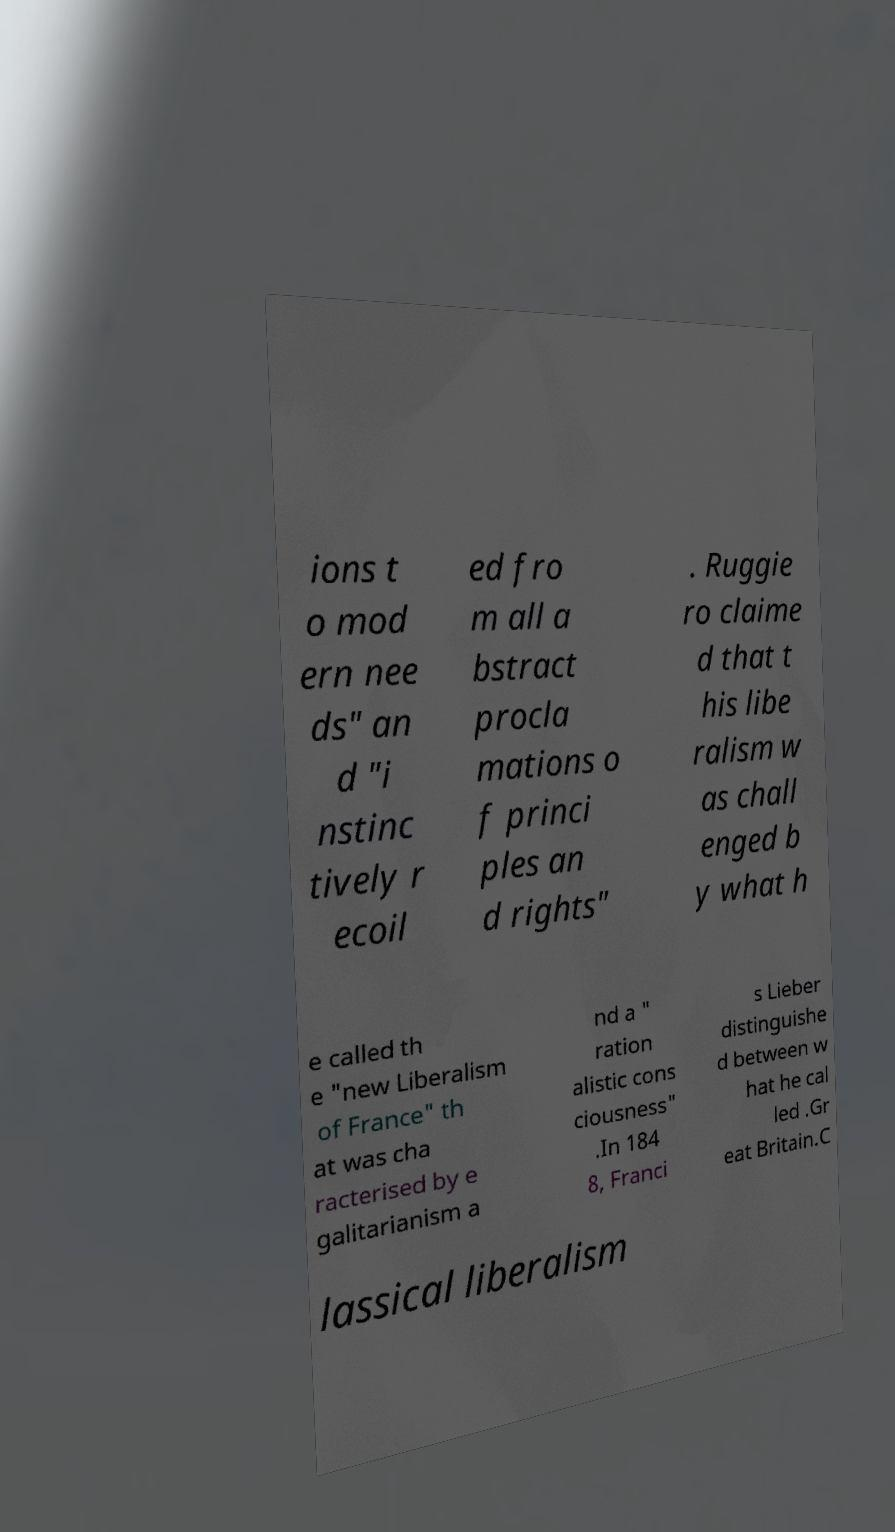Can you read and provide the text displayed in the image?This photo seems to have some interesting text. Can you extract and type it out for me? ions t o mod ern nee ds" an d "i nstinc tively r ecoil ed fro m all a bstract procla mations o f princi ples an d rights" . Ruggie ro claime d that t his libe ralism w as chall enged b y what h e called th e "new Liberalism of France" th at was cha racterised by e galitarianism a nd a " ration alistic cons ciousness" .In 184 8, Franci s Lieber distinguishe d between w hat he cal led .Gr eat Britain.C lassical liberalism 